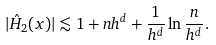Convert formula to latex. <formula><loc_0><loc_0><loc_500><loc_500>| \hat { H } _ { 2 } ( x ) | \lesssim 1 + n h ^ { d } + \frac { 1 } { h ^ { d } } \ln \frac { n } { h ^ { d } } .</formula> 